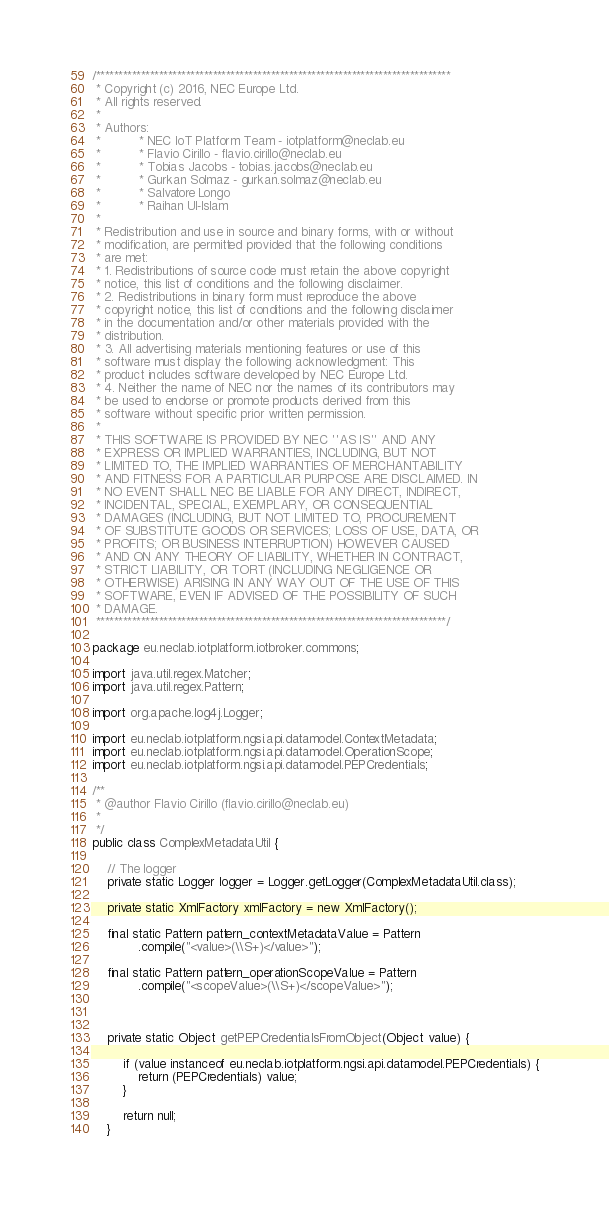<code> <loc_0><loc_0><loc_500><loc_500><_Java_>/*******************************************************************************
 * Copyright (c) 2016, NEC Europe Ltd.
 * All rights reserved.
 * 
 * Authors:
 *          * NEC IoT Platform Team - iotplatform@neclab.eu
 *          * Flavio Cirillo - flavio.cirillo@neclab.eu
 *          * Tobias Jacobs - tobias.jacobs@neclab.eu
 *          * Gurkan Solmaz - gurkan.solmaz@neclab.eu
 *          * Salvatore Longo
 *          * Raihan Ul-Islam
 * 
 * Redistribution and use in source and binary forms, with or without
 * modification, are permitted provided that the following conditions 
 * are met:
 * 1. Redistributions of source code must retain the above copyright 
 * notice, this list of conditions and the following disclaimer.
 * 2. Redistributions in binary form must reproduce the above 
 * copyright notice, this list of conditions and the following disclaimer 
 * in the documentation and/or other materials provided with the 
 * distribution.
 * 3. All advertising materials mentioning features or use of this 
 * software must display the following acknowledgment: This 
 * product includes software developed by NEC Europe Ltd.
 * 4. Neither the name of NEC nor the names of its contributors may 
 * be used to endorse or promote products derived from this 
 * software without specific prior written permission.
 * 
 * THIS SOFTWARE IS PROVIDED BY NEC ''AS IS'' AND ANY 
 * EXPRESS OR IMPLIED WARRANTIES, INCLUDING, BUT NOT 
 * LIMITED TO, THE IMPLIED WARRANTIES OF MERCHANTABILITY 
 * AND FITNESS FOR A PARTICULAR PURPOSE ARE DISCLAIMED. IN 
 * NO EVENT SHALL NEC BE LIABLE FOR ANY DIRECT, INDIRECT, 
 * INCIDENTAL, SPECIAL, EXEMPLARY, OR CONSEQUENTIAL 
 * DAMAGES (INCLUDING, BUT NOT LIMITED TO, PROCUREMENT 
 * OF SUBSTITUTE GOODS OR SERVICES; LOSS OF USE, DATA, OR 
 * PROFITS; OR BUSINESS INTERRUPTION) HOWEVER CAUSED 
 * AND ON ANY THEORY OF LIABILITY, WHETHER IN CONTRACT, 
 * STRICT LIABILITY, OR TORT (INCLUDING NEGLIGENCE OR 
 * OTHERWISE) ARISING IN ANY WAY OUT OF THE USE OF THIS 
 * SOFTWARE, EVEN IF ADVISED OF THE POSSIBILITY OF SUCH 
 * DAMAGE.
 ******************************************************************************/

package eu.neclab.iotplatform.iotbroker.commons;

import java.util.regex.Matcher;
import java.util.regex.Pattern;

import org.apache.log4j.Logger;

import eu.neclab.iotplatform.ngsi.api.datamodel.ContextMetadata;
import eu.neclab.iotplatform.ngsi.api.datamodel.OperationScope;
import eu.neclab.iotplatform.ngsi.api.datamodel.PEPCredentials;

/**
 * @author Flavio Cirillo (flavio.cirillo@neclab.eu)
 * 
 */
public class ComplexMetadataUtil {

	// The logger
	private static Logger logger = Logger.getLogger(ComplexMetadataUtil.class);

	private static XmlFactory xmlFactory = new XmlFactory();

	final static Pattern pattern_contextMetadataValue = Pattern
			.compile("<value>(\\S+)</value>");

	final static Pattern pattern_operationScopeValue = Pattern
			.compile("<scopeValue>(\\S+)</scopeValue>");



	private static Object getPEPCredentialsFromObject(Object value) {

		if (value instanceof eu.neclab.iotplatform.ngsi.api.datamodel.PEPCredentials) {
			return (PEPCredentials) value;
		}

		return null;
	}
</code> 